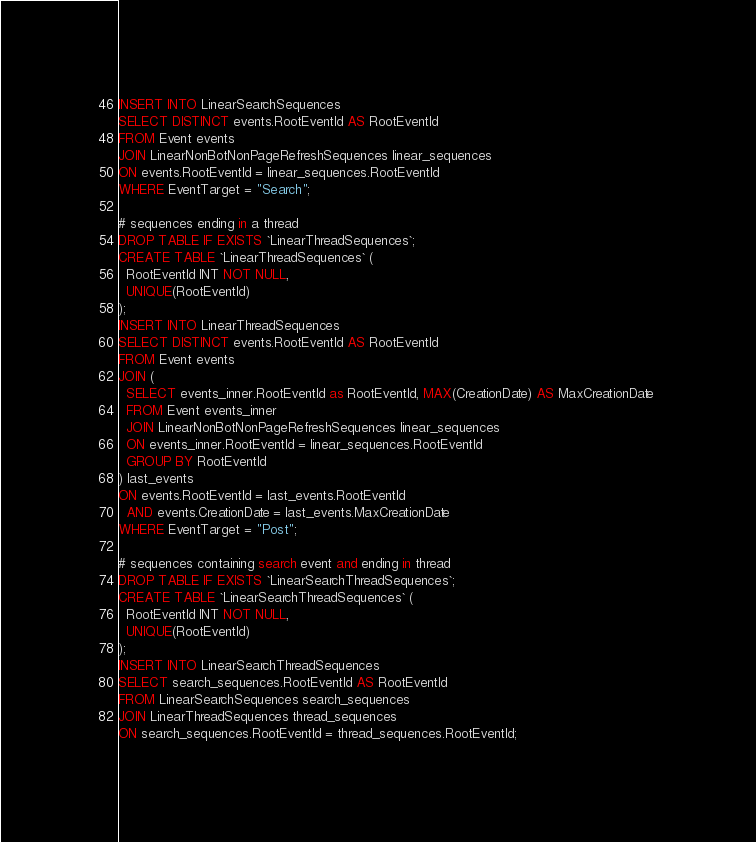Convert code to text. <code><loc_0><loc_0><loc_500><loc_500><_SQL_>INSERT INTO LinearSearchSequences
SELECT DISTINCT events.RootEventId AS RootEventId
FROM Event events
JOIN LinearNonBotNonPageRefreshSequences linear_sequences
ON events.RootEventId = linear_sequences.RootEventId
WHERE EventTarget = "Search";

# sequences ending in a thread
DROP TABLE IF EXISTS `LinearThreadSequences`;
CREATE TABLE `LinearThreadSequences` (
  RootEventId INT NOT NULL,
  UNIQUE(RootEventId)
);
INSERT INTO LinearThreadSequences
SELECT DISTINCT events.RootEventId AS RootEventId
FROM Event events
JOIN (
  SELECT events_inner.RootEventId as RootEventId, MAX(CreationDate) AS MaxCreationDate 
  FROM Event events_inner
  JOIN LinearNonBotNonPageRefreshSequences linear_sequences
  ON events_inner.RootEventId = linear_sequences.RootEventId
  GROUP BY RootEventId
) last_events
ON events.RootEventId = last_events.RootEventId
  AND events.CreationDate = last_events.MaxCreationDate
WHERE EventTarget = "Post";

# sequences containing search event and ending in thread
DROP TABLE IF EXISTS `LinearSearchThreadSequences`;
CREATE TABLE `LinearSearchThreadSequences` (
  RootEventId INT NOT NULL,
  UNIQUE(RootEventId)
);
INSERT INTO LinearSearchThreadSequences
SELECT search_sequences.RootEventId AS RootEventId
FROM LinearSearchSequences search_sequences
JOIN LinearThreadSequences thread_sequences
ON search_sequences.RootEventId = thread_sequences.RootEventId;
</code> 